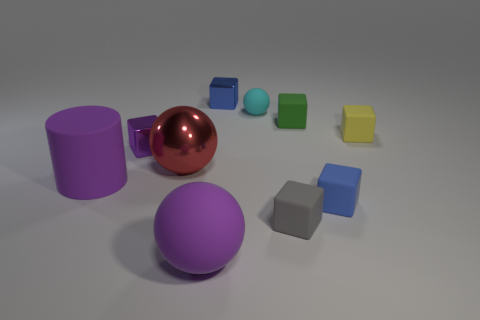There is a gray rubber object; are there any tiny yellow rubber blocks on the right side of it?
Your answer should be compact. Yes. There is a matte ball that is the same size as the yellow cube; what is its color?
Give a very brief answer. Cyan. What number of big red objects are the same material as the gray block?
Your response must be concise. 0. How many other objects are there of the same size as the cyan rubber sphere?
Provide a short and direct response. 6. Is there a purple rubber cylinder of the same size as the red sphere?
Ensure brevity in your answer.  Yes. Do the metallic block left of the large red thing and the big matte cylinder have the same color?
Ensure brevity in your answer.  Yes. How many things are big purple cubes or tiny blue matte objects?
Keep it short and to the point. 1. Do the blue block that is to the right of the green object and the small purple metal cube have the same size?
Your answer should be compact. Yes. What size is the block that is on the left side of the blue rubber thing and to the right of the tiny gray block?
Your answer should be compact. Small. How many other objects are there of the same shape as the tiny yellow matte thing?
Your answer should be compact. 5. 